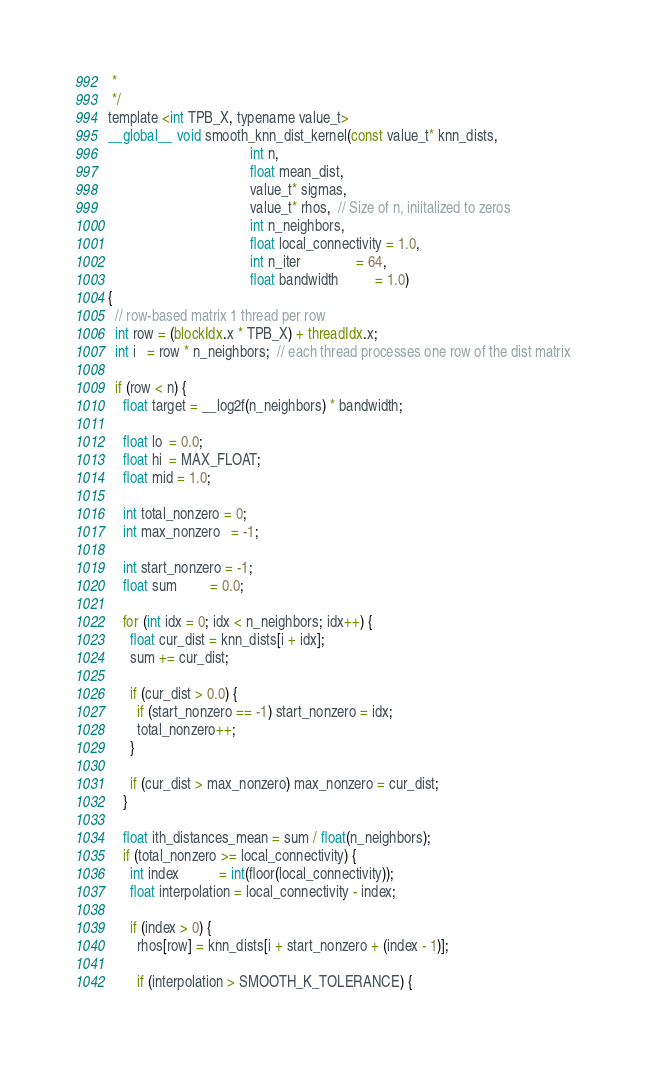<code> <loc_0><loc_0><loc_500><loc_500><_Cuda_> *
 */
template <int TPB_X, typename value_t>
__global__ void smooth_knn_dist_kernel(const value_t* knn_dists,
                                       int n,
                                       float mean_dist,
                                       value_t* sigmas,
                                       value_t* rhos,  // Size of n, iniitalized to zeros
                                       int n_neighbors,
                                       float local_connectivity = 1.0,
                                       int n_iter               = 64,
                                       float bandwidth          = 1.0)
{
  // row-based matrix 1 thread per row
  int row = (blockIdx.x * TPB_X) + threadIdx.x;
  int i   = row * n_neighbors;  // each thread processes one row of the dist matrix

  if (row < n) {
    float target = __log2f(n_neighbors) * bandwidth;

    float lo  = 0.0;
    float hi  = MAX_FLOAT;
    float mid = 1.0;

    int total_nonzero = 0;
    int max_nonzero   = -1;

    int start_nonzero = -1;
    float sum         = 0.0;

    for (int idx = 0; idx < n_neighbors; idx++) {
      float cur_dist = knn_dists[i + idx];
      sum += cur_dist;

      if (cur_dist > 0.0) {
        if (start_nonzero == -1) start_nonzero = idx;
        total_nonzero++;
      }

      if (cur_dist > max_nonzero) max_nonzero = cur_dist;
    }

    float ith_distances_mean = sum / float(n_neighbors);
    if (total_nonzero >= local_connectivity) {
      int index           = int(floor(local_connectivity));
      float interpolation = local_connectivity - index;

      if (index > 0) {
        rhos[row] = knn_dists[i + start_nonzero + (index - 1)];

        if (interpolation > SMOOTH_K_TOLERANCE) {</code> 